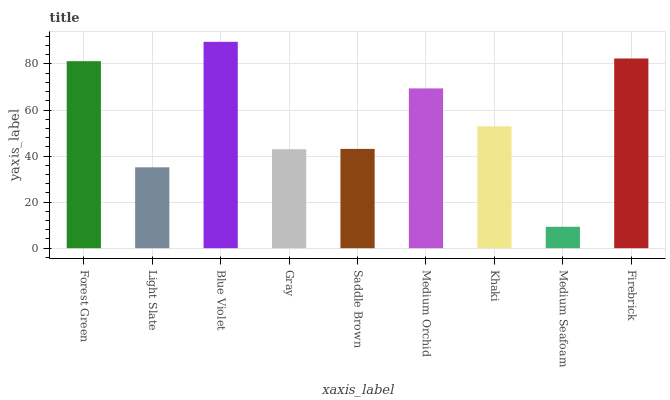Is Medium Seafoam the minimum?
Answer yes or no. Yes. Is Blue Violet the maximum?
Answer yes or no. Yes. Is Light Slate the minimum?
Answer yes or no. No. Is Light Slate the maximum?
Answer yes or no. No. Is Forest Green greater than Light Slate?
Answer yes or no. Yes. Is Light Slate less than Forest Green?
Answer yes or no. Yes. Is Light Slate greater than Forest Green?
Answer yes or no. No. Is Forest Green less than Light Slate?
Answer yes or no. No. Is Khaki the high median?
Answer yes or no. Yes. Is Khaki the low median?
Answer yes or no. Yes. Is Blue Violet the high median?
Answer yes or no. No. Is Medium Orchid the low median?
Answer yes or no. No. 